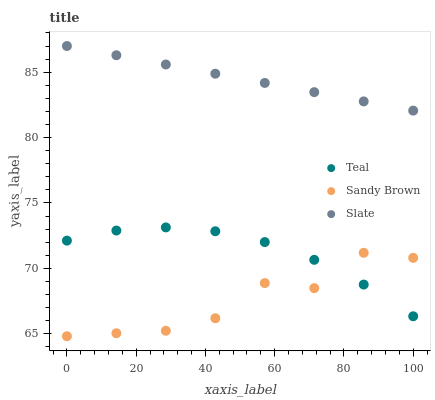Does Sandy Brown have the minimum area under the curve?
Answer yes or no. Yes. Does Slate have the maximum area under the curve?
Answer yes or no. Yes. Does Teal have the minimum area under the curve?
Answer yes or no. No. Does Teal have the maximum area under the curve?
Answer yes or no. No. Is Slate the smoothest?
Answer yes or no. Yes. Is Sandy Brown the roughest?
Answer yes or no. Yes. Is Teal the smoothest?
Answer yes or no. No. Is Teal the roughest?
Answer yes or no. No. Does Sandy Brown have the lowest value?
Answer yes or no. Yes. Does Teal have the lowest value?
Answer yes or no. No. Does Slate have the highest value?
Answer yes or no. Yes. Does Teal have the highest value?
Answer yes or no. No. Is Sandy Brown less than Slate?
Answer yes or no. Yes. Is Slate greater than Sandy Brown?
Answer yes or no. Yes. Does Teal intersect Sandy Brown?
Answer yes or no. Yes. Is Teal less than Sandy Brown?
Answer yes or no. No. Is Teal greater than Sandy Brown?
Answer yes or no. No. Does Sandy Brown intersect Slate?
Answer yes or no. No. 